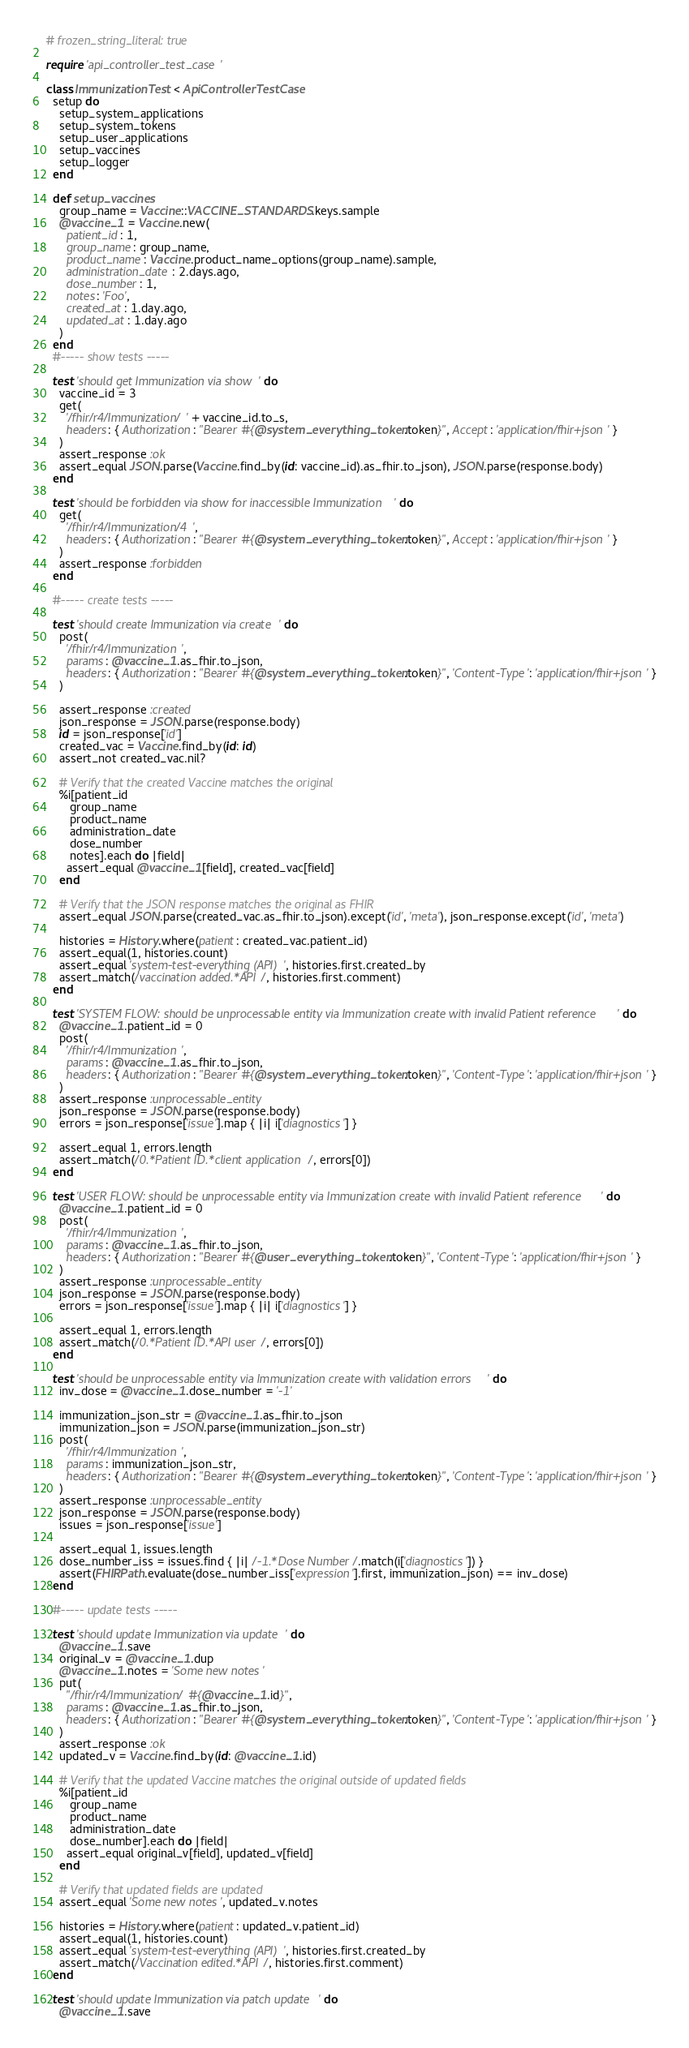<code> <loc_0><loc_0><loc_500><loc_500><_Ruby_># frozen_string_literal: true

require 'api_controller_test_case'

class ImmunizationTest < ApiControllerTestCase
  setup do
    setup_system_applications
    setup_system_tokens
    setup_user_applications
    setup_vaccines
    setup_logger
  end

  def setup_vaccines
    group_name = Vaccine::VACCINE_STANDARDS.keys.sample
    @vaccine_1 = Vaccine.new(
      patient_id: 1,
      group_name: group_name,
      product_name: Vaccine.product_name_options(group_name).sample,
      administration_date: 2.days.ago,
      dose_number: 1,
      notes: 'Foo',
      created_at: 1.day.ago,
      updated_at: 1.day.ago
    )
  end
  #----- show tests -----

  test 'should get Immunization via show' do
    vaccine_id = 3
    get(
      '/fhir/r4/Immunization/' + vaccine_id.to_s,
      headers: { Authorization: "Bearer #{@system_everything_token.token}", Accept: 'application/fhir+json' }
    )
    assert_response :ok
    assert_equal JSON.parse(Vaccine.find_by(id: vaccine_id).as_fhir.to_json), JSON.parse(response.body)
  end

  test 'should be forbidden via show for inaccessible Immunization' do
    get(
      '/fhir/r4/Immunization/4',
      headers: { Authorization: "Bearer #{@system_everything_token.token}", Accept: 'application/fhir+json' }
    )
    assert_response :forbidden
  end

  #----- create tests -----

  test 'should create Immunization via create' do
    post(
      '/fhir/r4/Immunization',
      params: @vaccine_1.as_fhir.to_json,
      headers: { Authorization: "Bearer #{@system_everything_token.token}", 'Content-Type': 'application/fhir+json' }
    )

    assert_response :created
    json_response = JSON.parse(response.body)
    id = json_response['id']
    created_vac = Vaccine.find_by(id: id)
    assert_not created_vac.nil?

    # Verify that the created Vaccine matches the original
    %i[patient_id
       group_name
       product_name
       administration_date
       dose_number
       notes].each do |field|
      assert_equal @vaccine_1[field], created_vac[field]
    end

    # Verify that the JSON response matches the original as FHIR
    assert_equal JSON.parse(created_vac.as_fhir.to_json).except('id', 'meta'), json_response.except('id', 'meta')

    histories = History.where(patient: created_vac.patient_id)
    assert_equal(1, histories.count)
    assert_equal 'system-test-everything (API)', histories.first.created_by
    assert_match(/vaccination added.*API/, histories.first.comment)
  end

  test 'SYSTEM FLOW: should be unprocessable entity via Immunization create with invalid Patient reference' do
    @vaccine_1.patient_id = 0
    post(
      '/fhir/r4/Immunization',
      params: @vaccine_1.as_fhir.to_json,
      headers: { Authorization: "Bearer #{@system_everything_token.token}", 'Content-Type': 'application/fhir+json' }
    )
    assert_response :unprocessable_entity
    json_response = JSON.parse(response.body)
    errors = json_response['issue'].map { |i| i['diagnostics'] }

    assert_equal 1, errors.length
    assert_match(/0.*Patient ID.*client application/, errors[0])
  end

  test 'USER FLOW: should be unprocessable entity via Immunization create with invalid Patient reference' do
    @vaccine_1.patient_id = 0
    post(
      '/fhir/r4/Immunization',
      params: @vaccine_1.as_fhir.to_json,
      headers: { Authorization: "Bearer #{@user_everything_token.token}", 'Content-Type': 'application/fhir+json' }
    )
    assert_response :unprocessable_entity
    json_response = JSON.parse(response.body)
    errors = json_response['issue'].map { |i| i['diagnostics'] }

    assert_equal 1, errors.length
    assert_match(/0.*Patient ID.*API user/, errors[0])
  end

  test 'should be unprocessable entity via Immunization create with validation errors' do
    inv_dose = @vaccine_1.dose_number = '-1'

    immunization_json_str = @vaccine_1.as_fhir.to_json
    immunization_json = JSON.parse(immunization_json_str)
    post(
      '/fhir/r4/Immunization',
      params: immunization_json_str,
      headers: { Authorization: "Bearer #{@system_everything_token.token}", 'Content-Type': 'application/fhir+json' }
    )
    assert_response :unprocessable_entity
    json_response = JSON.parse(response.body)
    issues = json_response['issue']

    assert_equal 1, issues.length
    dose_number_iss = issues.find { |i| /-1.*Dose Number/.match(i['diagnostics']) }
    assert(FHIRPath.evaluate(dose_number_iss['expression'].first, immunization_json) == inv_dose)
  end

  #----- update tests -----

  test 'should update Immunization via update' do
    @vaccine_1.save
    original_v = @vaccine_1.dup
    @vaccine_1.notes = 'Some new notes'
    put(
      "/fhir/r4/Immunization/#{@vaccine_1.id}",
      params: @vaccine_1.as_fhir.to_json,
      headers: { Authorization: "Bearer #{@system_everything_token.token}", 'Content-Type': 'application/fhir+json' }
    )
    assert_response :ok
    updated_v = Vaccine.find_by(id: @vaccine_1.id)

    # Verify that the updated Vaccine matches the original outside of updated fields
    %i[patient_id
       group_name
       product_name
       administration_date
       dose_number].each do |field|
      assert_equal original_v[field], updated_v[field]
    end

    # Verify that updated fields are updated
    assert_equal 'Some new notes', updated_v.notes

    histories = History.where(patient: updated_v.patient_id)
    assert_equal(1, histories.count)
    assert_equal 'system-test-everything (API)', histories.first.created_by
    assert_match(/Vaccination edited.*API/, histories.first.comment)
  end

  test 'should update Immunization via patch update' do
    @vaccine_1.save</code> 